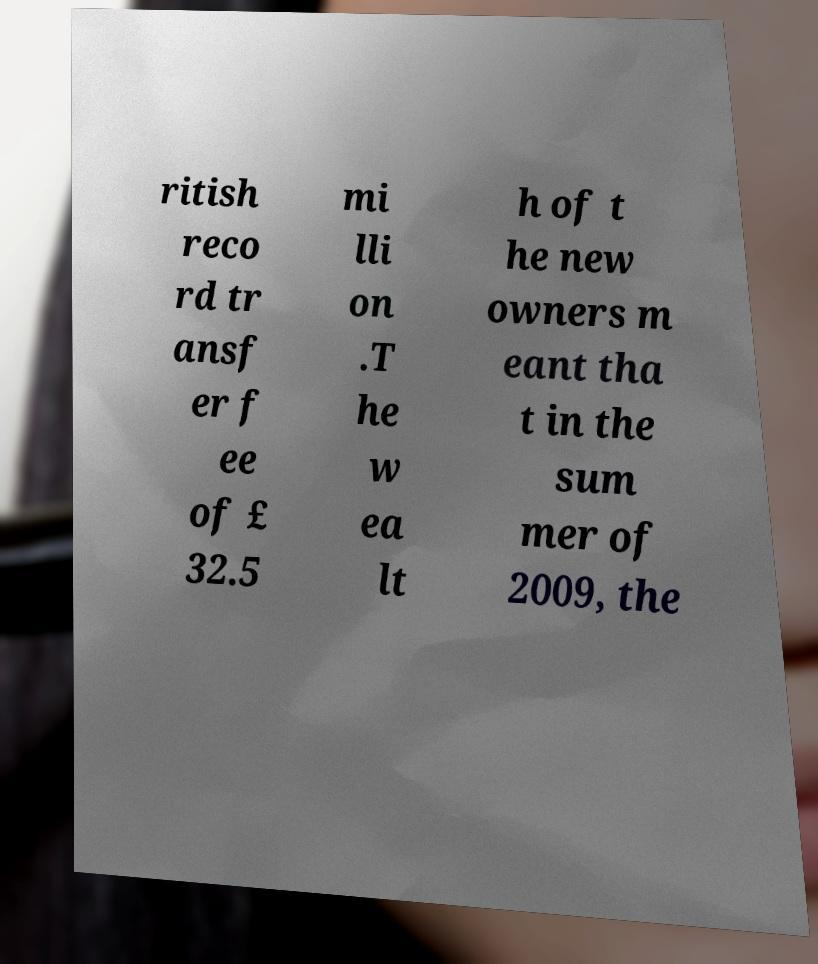For documentation purposes, I need the text within this image transcribed. Could you provide that? ritish reco rd tr ansf er f ee of £ 32.5 mi lli on .T he w ea lt h of t he new owners m eant tha t in the sum mer of 2009, the 